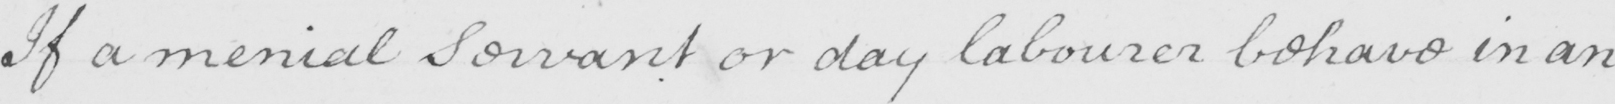Please transcribe the handwritten text in this image. If a menial servant or day labourer behave in an 